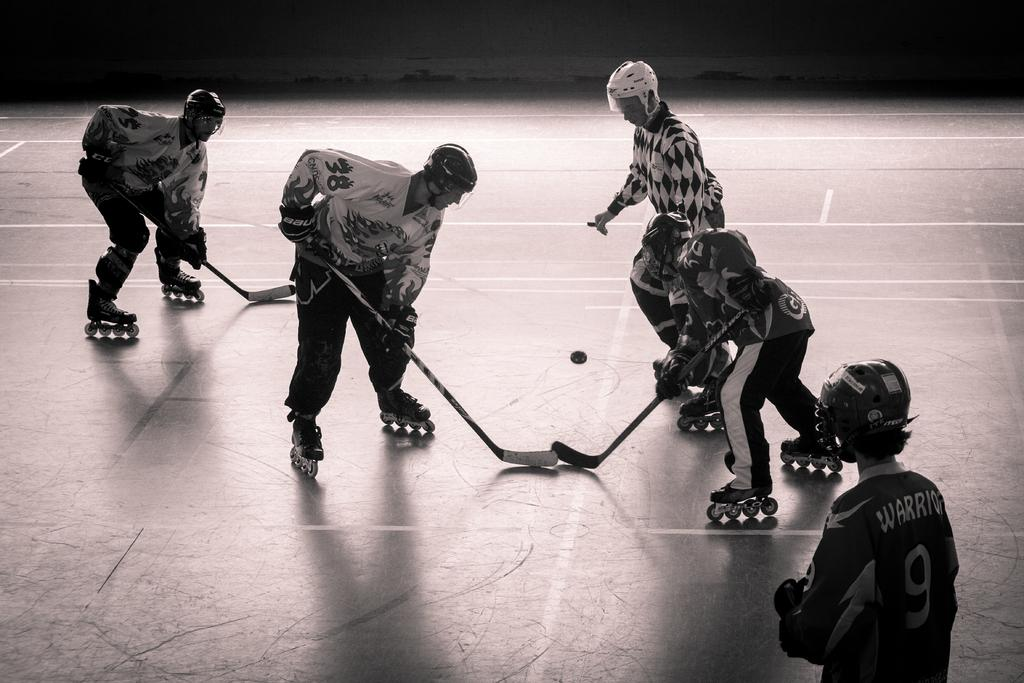What are the men in the image doing? The men are playing roller hockey in the image. What equipment are the men using to play roller hockey? The men are holding bats in the image. What type of footwear are the men wearing? The men are wearing skates in the image. Where are the men playing roller hockey? The men are on the floor in the image. What is the color scheme of the image? The image is black and white. How does the rainstorm affect the men's roller hockey game in the image? There is no rainstorm present in the image; it is a black and white image of men playing roller hockey. What need do the men have to continue playing roller hockey in the image? The question assumes a need that cannot be determined from the image. The men are already playing roller hockey, so there is no indication of any additional needs. 